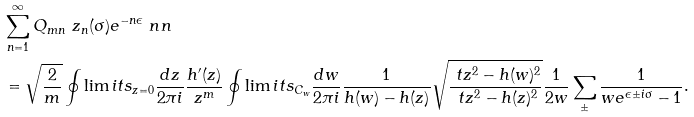Convert formula to latex. <formula><loc_0><loc_0><loc_500><loc_500>& \sum _ { n = 1 } ^ { \infty } Q _ { m n } \ z _ { n } ( \sigma ) e ^ { - n \epsilon } \ n n \\ & = \sqrt { \frac { 2 } { m } } \oint \lim i t s _ { z = 0 } \frac { d z } { 2 \pi i } \frac { h ^ { \prime } ( z ) } { z ^ { m } } \oint \lim i t s _ { C _ { w } } \frac { d w } { 2 \pi i } \frac { 1 } { h ( w ) - h ( z ) } \sqrt { \frac { \ t z ^ { 2 } - h ( w ) ^ { 2 } } { \ t z ^ { 2 } - h ( z ) ^ { 2 } } } \frac { 1 } { 2 w } \sum _ { \pm } \frac { 1 } { w e ^ { \epsilon \pm i \sigma } - 1 } .</formula> 